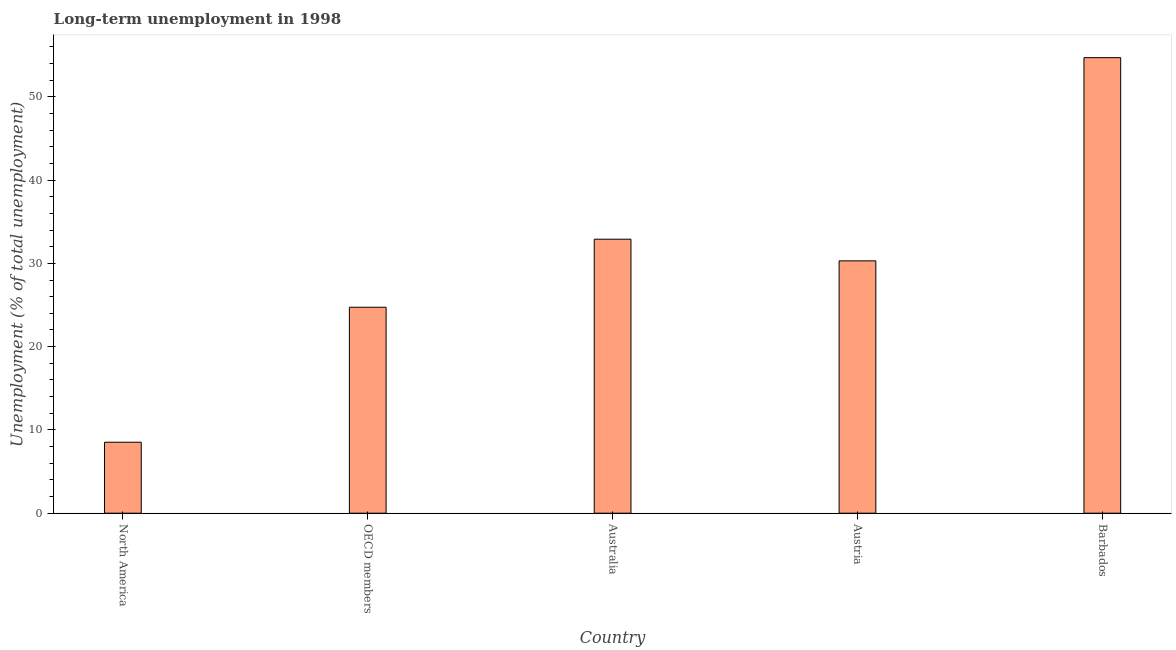What is the title of the graph?
Provide a succinct answer. Long-term unemployment in 1998. What is the label or title of the X-axis?
Offer a terse response. Country. What is the label or title of the Y-axis?
Offer a terse response. Unemployment (% of total unemployment). What is the long-term unemployment in OECD members?
Provide a succinct answer. 24.73. Across all countries, what is the maximum long-term unemployment?
Offer a very short reply. 54.7. Across all countries, what is the minimum long-term unemployment?
Keep it short and to the point. 8.52. In which country was the long-term unemployment maximum?
Ensure brevity in your answer.  Barbados. What is the sum of the long-term unemployment?
Provide a succinct answer. 151.15. What is the difference between the long-term unemployment in Austria and Barbados?
Keep it short and to the point. -24.4. What is the average long-term unemployment per country?
Keep it short and to the point. 30.23. What is the median long-term unemployment?
Provide a short and direct response. 30.3. What is the ratio of the long-term unemployment in Austria to that in Barbados?
Your answer should be compact. 0.55. What is the difference between the highest and the second highest long-term unemployment?
Make the answer very short. 21.8. Is the sum of the long-term unemployment in Barbados and OECD members greater than the maximum long-term unemployment across all countries?
Ensure brevity in your answer.  Yes. What is the difference between the highest and the lowest long-term unemployment?
Your answer should be very brief. 46.18. In how many countries, is the long-term unemployment greater than the average long-term unemployment taken over all countries?
Ensure brevity in your answer.  3. How many bars are there?
Give a very brief answer. 5. Are all the bars in the graph horizontal?
Ensure brevity in your answer.  No. How many countries are there in the graph?
Your answer should be compact. 5. What is the Unemployment (% of total unemployment) in North America?
Give a very brief answer. 8.52. What is the Unemployment (% of total unemployment) of OECD members?
Give a very brief answer. 24.73. What is the Unemployment (% of total unemployment) in Australia?
Your answer should be very brief. 32.9. What is the Unemployment (% of total unemployment) of Austria?
Ensure brevity in your answer.  30.3. What is the Unemployment (% of total unemployment) of Barbados?
Offer a terse response. 54.7. What is the difference between the Unemployment (% of total unemployment) in North America and OECD members?
Make the answer very short. -16.21. What is the difference between the Unemployment (% of total unemployment) in North America and Australia?
Your response must be concise. -24.38. What is the difference between the Unemployment (% of total unemployment) in North America and Austria?
Offer a very short reply. -21.78. What is the difference between the Unemployment (% of total unemployment) in North America and Barbados?
Your response must be concise. -46.18. What is the difference between the Unemployment (% of total unemployment) in OECD members and Australia?
Give a very brief answer. -8.17. What is the difference between the Unemployment (% of total unemployment) in OECD members and Austria?
Make the answer very short. -5.57. What is the difference between the Unemployment (% of total unemployment) in OECD members and Barbados?
Provide a succinct answer. -29.97. What is the difference between the Unemployment (% of total unemployment) in Australia and Barbados?
Your response must be concise. -21.8. What is the difference between the Unemployment (% of total unemployment) in Austria and Barbados?
Your response must be concise. -24.4. What is the ratio of the Unemployment (% of total unemployment) in North America to that in OECD members?
Provide a succinct answer. 0.34. What is the ratio of the Unemployment (% of total unemployment) in North America to that in Australia?
Your answer should be compact. 0.26. What is the ratio of the Unemployment (% of total unemployment) in North America to that in Austria?
Keep it short and to the point. 0.28. What is the ratio of the Unemployment (% of total unemployment) in North America to that in Barbados?
Offer a terse response. 0.16. What is the ratio of the Unemployment (% of total unemployment) in OECD members to that in Australia?
Ensure brevity in your answer.  0.75. What is the ratio of the Unemployment (% of total unemployment) in OECD members to that in Austria?
Provide a short and direct response. 0.82. What is the ratio of the Unemployment (% of total unemployment) in OECD members to that in Barbados?
Offer a terse response. 0.45. What is the ratio of the Unemployment (% of total unemployment) in Australia to that in Austria?
Keep it short and to the point. 1.09. What is the ratio of the Unemployment (% of total unemployment) in Australia to that in Barbados?
Your answer should be very brief. 0.6. What is the ratio of the Unemployment (% of total unemployment) in Austria to that in Barbados?
Keep it short and to the point. 0.55. 